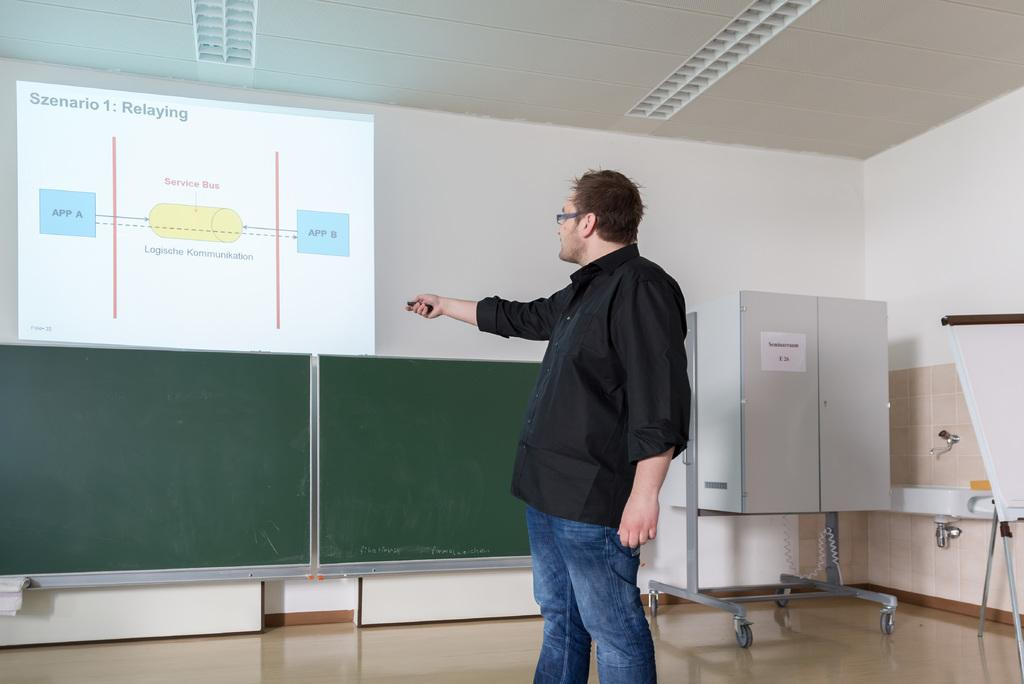<image>
Provide a brief description of the given image. A man pointing at a presentation that says Szenario 1 